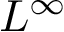Convert formula to latex. <formula><loc_0><loc_0><loc_500><loc_500>L ^ { \infty }</formula> 